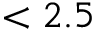Convert formula to latex. <formula><loc_0><loc_0><loc_500><loc_500>< 2 . 5</formula> 